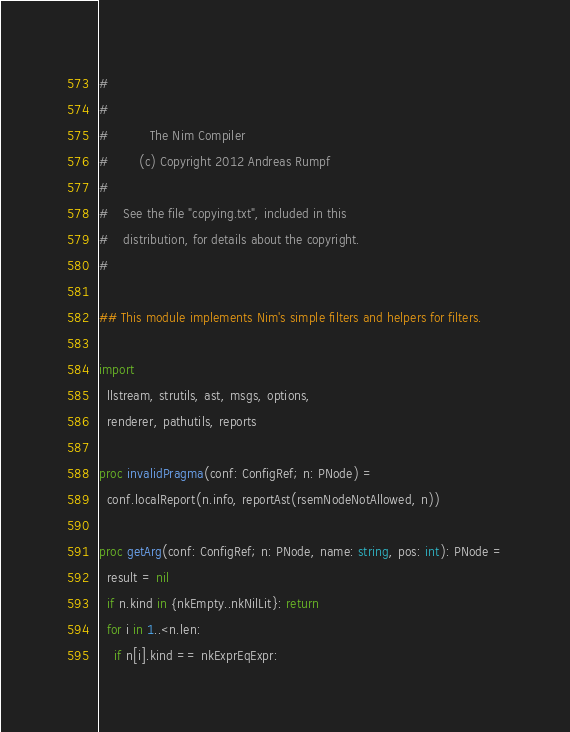<code> <loc_0><loc_0><loc_500><loc_500><_Nim_>#
#
#           The Nim Compiler
#        (c) Copyright 2012 Andreas Rumpf
#
#    See the file "copying.txt", included in this
#    distribution, for details about the copyright.
#

## This module implements Nim's simple filters and helpers for filters.

import
  llstream, strutils, ast, msgs, options,
  renderer, pathutils, reports

proc invalidPragma(conf: ConfigRef; n: PNode) =
  conf.localReport(n.info, reportAst(rsemNodeNotAllowed, n))

proc getArg(conf: ConfigRef; n: PNode, name: string, pos: int): PNode =
  result = nil
  if n.kind in {nkEmpty..nkNilLit}: return
  for i in 1..<n.len:
    if n[i].kind == nkExprEqExpr:</code> 